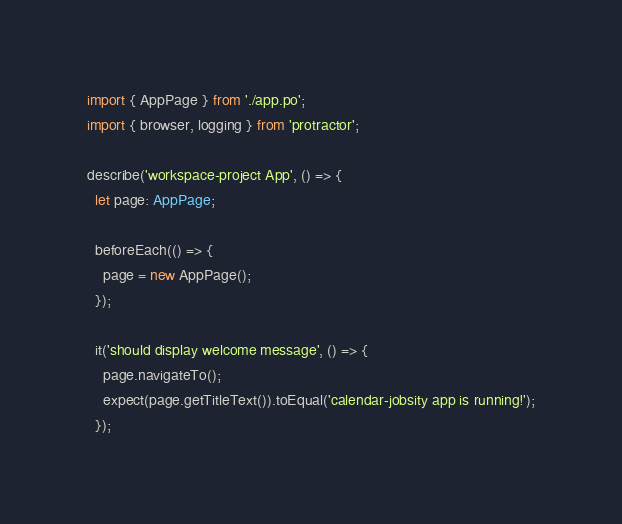Convert code to text. <code><loc_0><loc_0><loc_500><loc_500><_TypeScript_>import { AppPage } from './app.po';
import { browser, logging } from 'protractor';

describe('workspace-project App', () => {
  let page: AppPage;

  beforeEach(() => {
    page = new AppPage();
  });

  it('should display welcome message', () => {
    page.navigateTo();
    expect(page.getTitleText()).toEqual('calendar-jobsity app is running!');
  });
</code> 